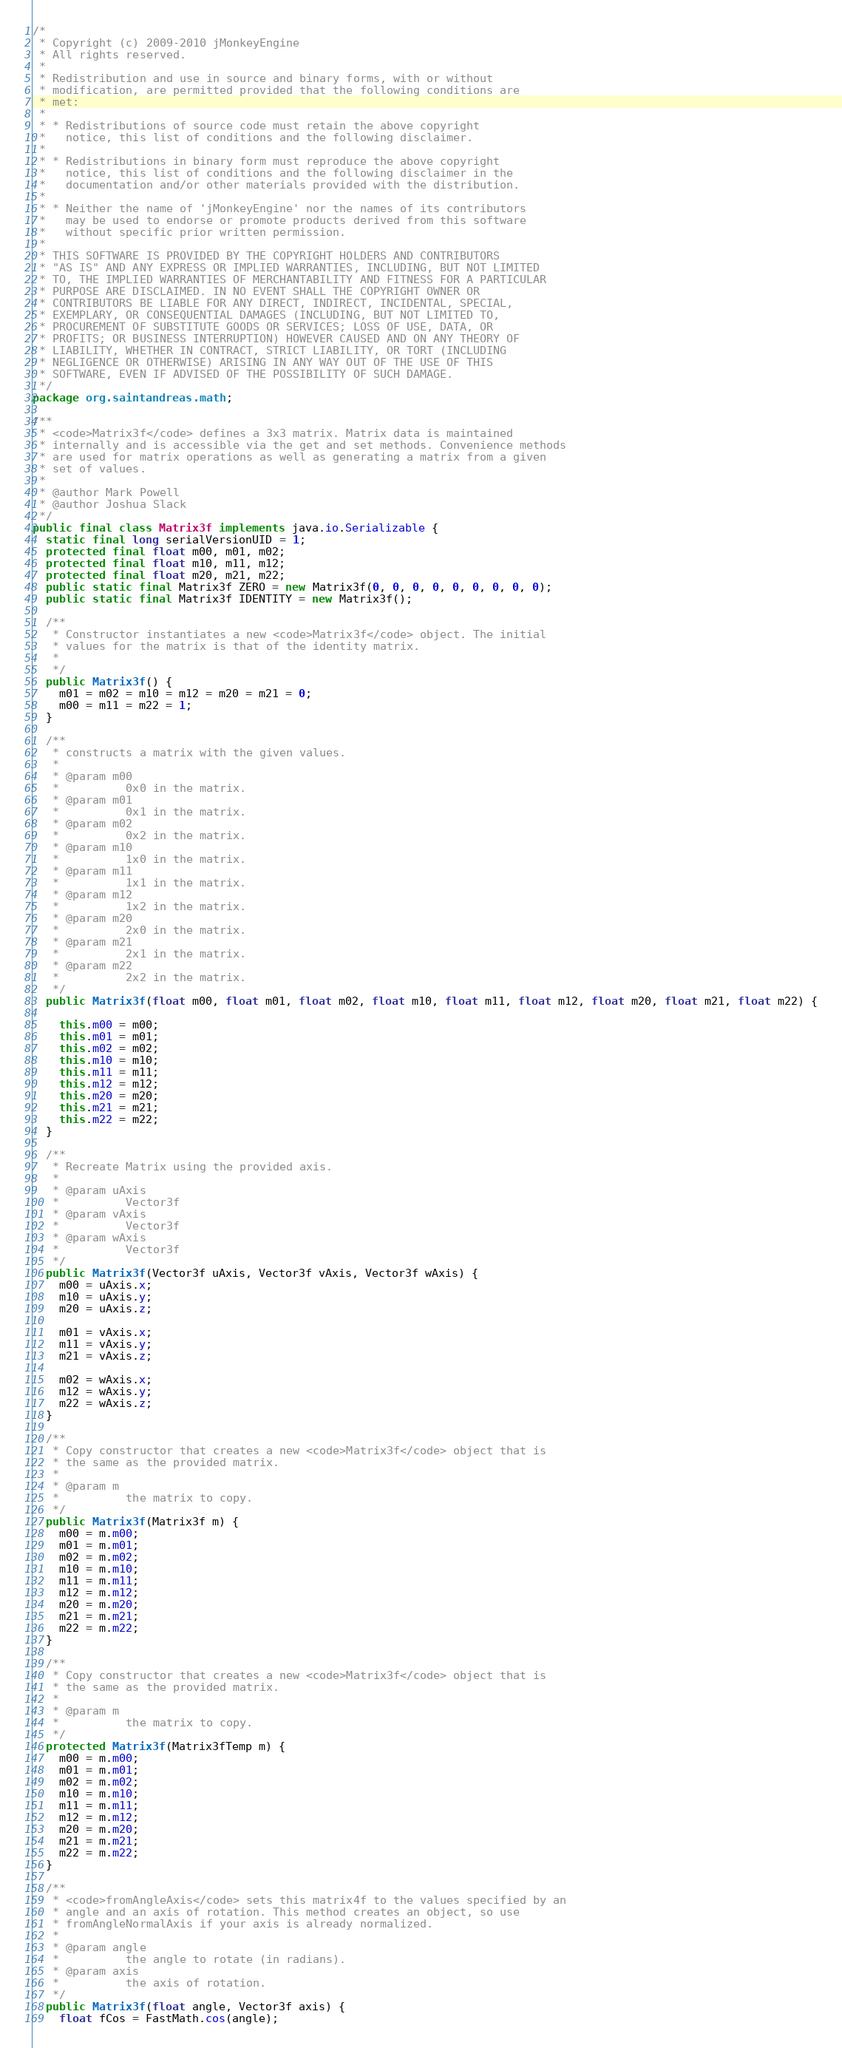<code> <loc_0><loc_0><loc_500><loc_500><_Java_>/*
 * Copyright (c) 2009-2010 jMonkeyEngine
 * All rights reserved.
 *
 * Redistribution and use in source and binary forms, with or without
 * modification, are permitted provided that the following conditions are
 * met:
 *
 * * Redistributions of source code must retain the above copyright
 *   notice, this list of conditions and the following disclaimer.
 *
 * * Redistributions in binary form must reproduce the above copyright
 *   notice, this list of conditions and the following disclaimer in the
 *   documentation and/or other materials provided with the distribution.
 *
 * * Neither the name of 'jMonkeyEngine' nor the names of its contributors
 *   may be used to endorse or promote products derived from this software
 *   without specific prior written permission.
 *
 * THIS SOFTWARE IS PROVIDED BY THE COPYRIGHT HOLDERS AND CONTRIBUTORS
 * "AS IS" AND ANY EXPRESS OR IMPLIED WARRANTIES, INCLUDING, BUT NOT LIMITED
 * TO, THE IMPLIED WARRANTIES OF MERCHANTABILITY AND FITNESS FOR A PARTICULAR
 * PURPOSE ARE DISCLAIMED. IN NO EVENT SHALL THE COPYRIGHT OWNER OR
 * CONTRIBUTORS BE LIABLE FOR ANY DIRECT, INDIRECT, INCIDENTAL, SPECIAL,
 * EXEMPLARY, OR CONSEQUENTIAL DAMAGES (INCLUDING, BUT NOT LIMITED TO,
 * PROCUREMENT OF SUBSTITUTE GOODS OR SERVICES; LOSS OF USE, DATA, OR
 * PROFITS; OR BUSINESS INTERRUPTION) HOWEVER CAUSED AND ON ANY THEORY OF
 * LIABILITY, WHETHER IN CONTRACT, STRICT LIABILITY, OR TORT (INCLUDING
 * NEGLIGENCE OR OTHERWISE) ARISING IN ANY WAY OUT OF THE USE OF THIS
 * SOFTWARE, EVEN IF ADVISED OF THE POSSIBILITY OF SUCH DAMAGE.
 */
package org.saintandreas.math;

/**
 * <code>Matrix3f</code> defines a 3x3 matrix. Matrix data is maintained
 * internally and is accessible via the get and set methods. Convenience methods
 * are used for matrix operations as well as generating a matrix from a given
 * set of values.
 * 
 * @author Mark Powell
 * @author Joshua Slack
 */
public final class Matrix3f implements java.io.Serializable {
  static final long serialVersionUID = 1;
  protected final float m00, m01, m02;
  protected final float m10, m11, m12;
  protected final float m20, m21, m22;
  public static final Matrix3f ZERO = new Matrix3f(0, 0, 0, 0, 0, 0, 0, 0, 0);
  public static final Matrix3f IDENTITY = new Matrix3f();

  /**
   * Constructor instantiates a new <code>Matrix3f</code> object. The initial
   * values for the matrix is that of the identity matrix.
   * 
   */
  public Matrix3f() {
    m01 = m02 = m10 = m12 = m20 = m21 = 0;
    m00 = m11 = m22 = 1;
  }

  /**
   * constructs a matrix with the given values.
   * 
   * @param m00
   *          0x0 in the matrix.
   * @param m01
   *          0x1 in the matrix.
   * @param m02
   *          0x2 in the matrix.
   * @param m10
   *          1x0 in the matrix.
   * @param m11
   *          1x1 in the matrix.
   * @param m12
   *          1x2 in the matrix.
   * @param m20
   *          2x0 in the matrix.
   * @param m21
   *          2x1 in the matrix.
   * @param m22
   *          2x2 in the matrix.
   */
  public Matrix3f(float m00, float m01, float m02, float m10, float m11, float m12, float m20, float m21, float m22) {

    this.m00 = m00;
    this.m01 = m01;
    this.m02 = m02;
    this.m10 = m10;
    this.m11 = m11;
    this.m12 = m12;
    this.m20 = m20;
    this.m21 = m21;
    this.m22 = m22;
  }

  /**
   * Recreate Matrix using the provided axis.
   * 
   * @param uAxis
   *          Vector3f
   * @param vAxis
   *          Vector3f
   * @param wAxis
   *          Vector3f
   */
  public Matrix3f(Vector3f uAxis, Vector3f vAxis, Vector3f wAxis) {
    m00 = uAxis.x;
    m10 = uAxis.y;
    m20 = uAxis.z;

    m01 = vAxis.x;
    m11 = vAxis.y;
    m21 = vAxis.z;

    m02 = wAxis.x;
    m12 = wAxis.y;
    m22 = wAxis.z;
  }

  /**
   * Copy constructor that creates a new <code>Matrix3f</code> object that is
   * the same as the provided matrix.
   * 
   * @param m
   *          the matrix to copy.
   */
  public Matrix3f(Matrix3f m) {
    m00 = m.m00;
    m01 = m.m01;
    m02 = m.m02;
    m10 = m.m10;
    m11 = m.m11;
    m12 = m.m12;
    m20 = m.m20;
    m21 = m.m21;
    m22 = m.m22;
  }

  /**
   * Copy constructor that creates a new <code>Matrix3f</code> object that is
   * the same as the provided matrix.
   * 
   * @param m
   *          the matrix to copy.
   */
  protected Matrix3f(Matrix3fTemp m) {
    m00 = m.m00;
    m01 = m.m01;
    m02 = m.m02;
    m10 = m.m10;
    m11 = m.m11;
    m12 = m.m12;
    m20 = m.m20;
    m21 = m.m21;
    m22 = m.m22;
  }

  /**
   * <code>fromAngleAxis</code> sets this matrix4f to the values specified by an
   * angle and an axis of rotation. This method creates an object, so use
   * fromAngleNormalAxis if your axis is already normalized.
   * 
   * @param angle
   *          the angle to rotate (in radians).
   * @param axis
   *          the axis of rotation.
   */
  public Matrix3f(float angle, Vector3f axis) {
    float fCos = FastMath.cos(angle);</code> 